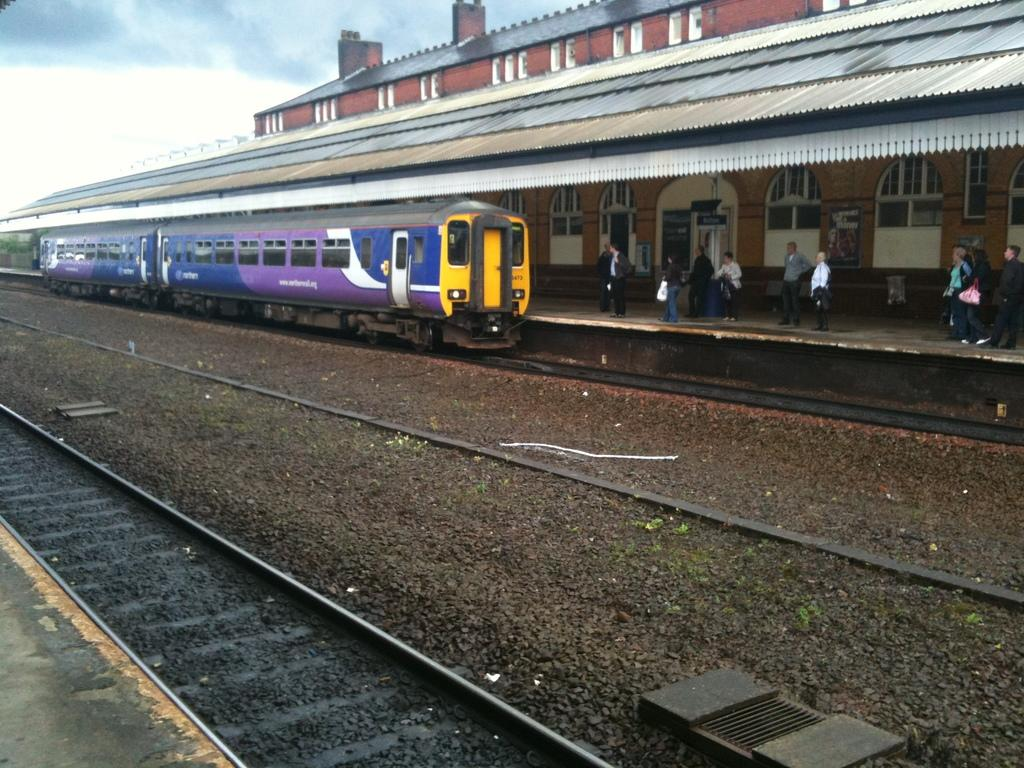What type of transportation infrastructure is depicted in the image? There is a railway station in the image. What can be seen alongside the railway station? There are railway tracks in the image. What mode of transportation is present at the railway station? There is a train in the image. What are the people on the platform doing? People are waiting on the platform for the train. What historical event is being commemorated by the grandfather in the image? There is no grandfather present in the image, and therefore no historical event can be commemorated. 